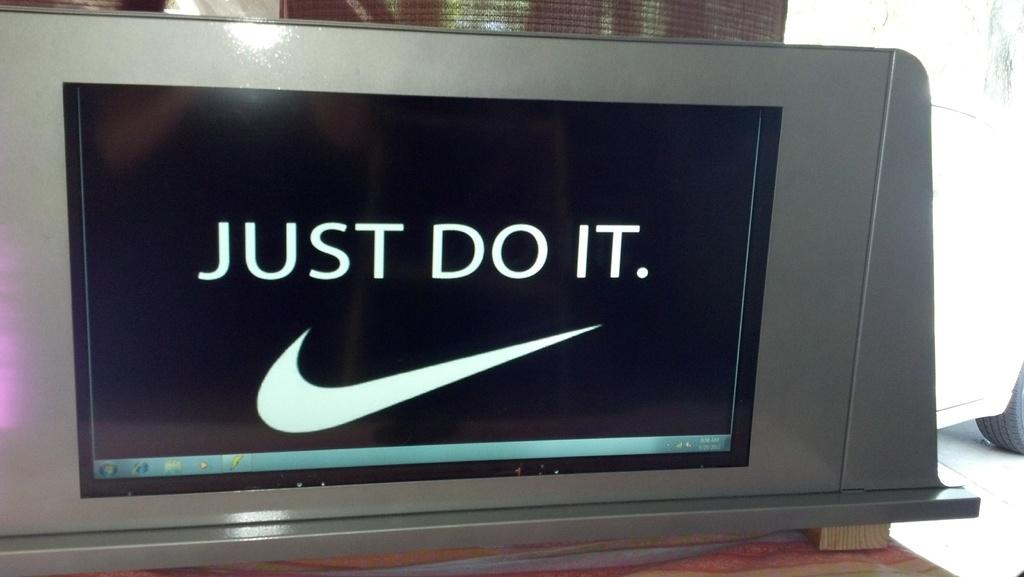<image>
Create a compact narrative representing the image presented. the words just do it are on the black surface 